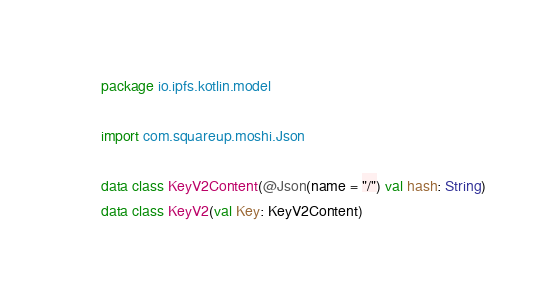Convert code to text. <code><loc_0><loc_0><loc_500><loc_500><_Kotlin_>package io.ipfs.kotlin.model

import com.squareup.moshi.Json

data class KeyV2Content(@Json(name = "/") val hash: String)
data class KeyV2(val Key: KeyV2Content)</code> 